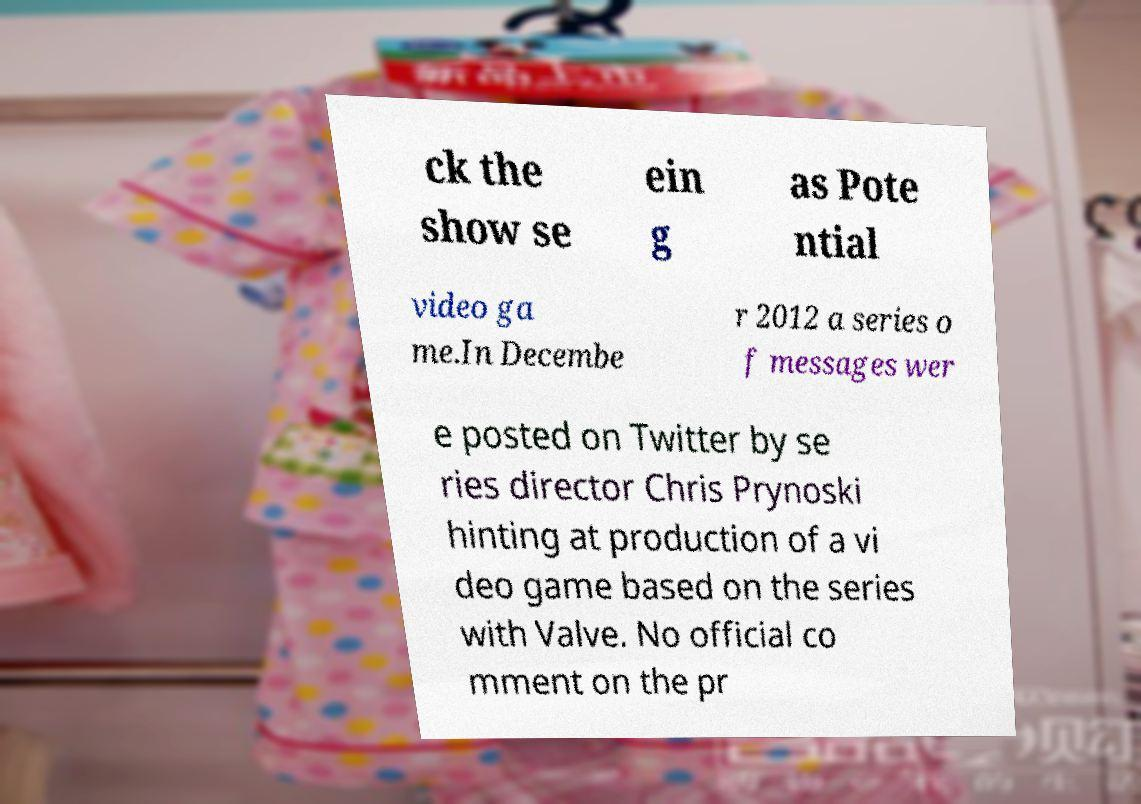For documentation purposes, I need the text within this image transcribed. Could you provide that? ck the show se ein g as Pote ntial video ga me.In Decembe r 2012 a series o f messages wer e posted on Twitter by se ries director Chris Prynoski hinting at production of a vi deo game based on the series with Valve. No official co mment on the pr 